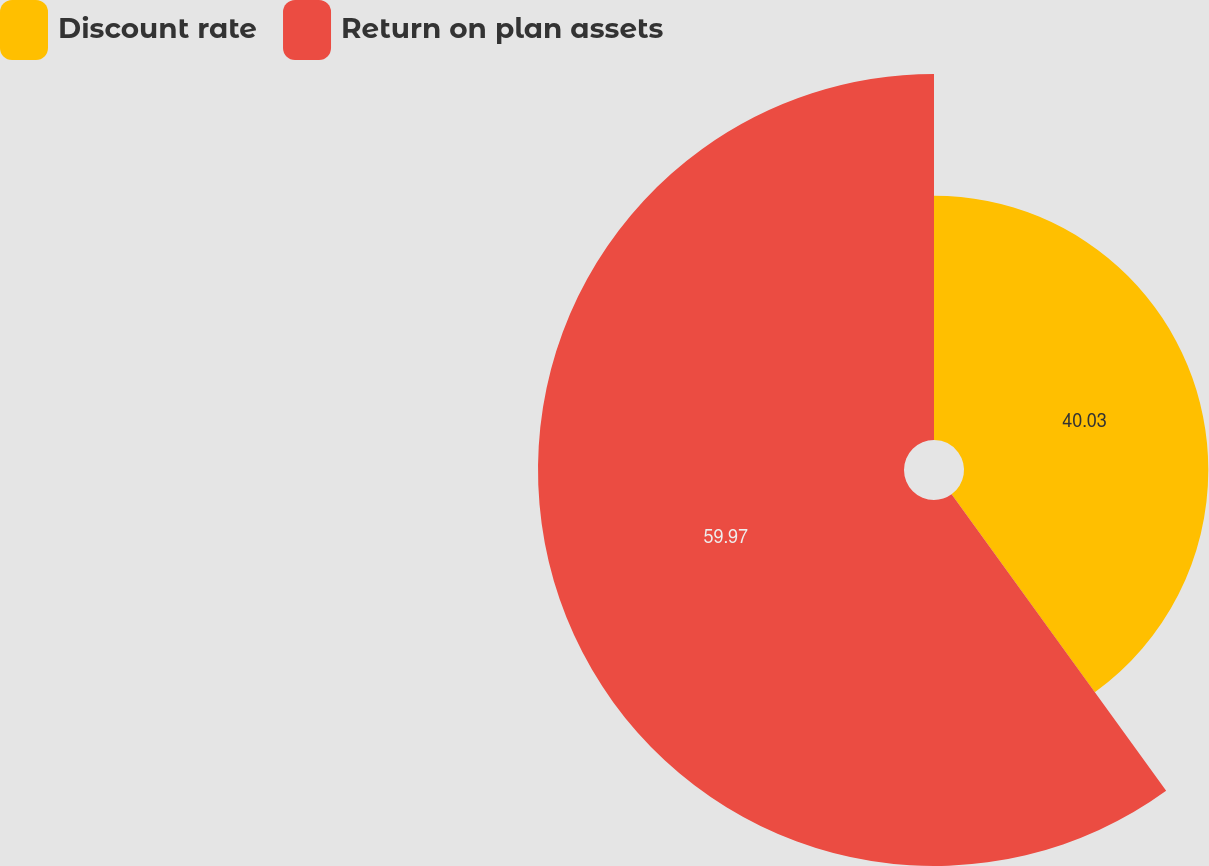Convert chart. <chart><loc_0><loc_0><loc_500><loc_500><pie_chart><fcel>Discount rate<fcel>Return on plan assets<nl><fcel>40.03%<fcel>59.97%<nl></chart> 